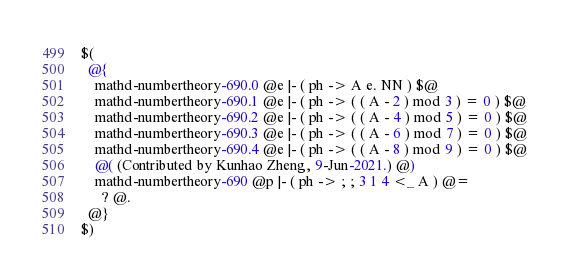<code> <loc_0><loc_0><loc_500><loc_500><_ObjectiveC_>$(
  @{
    mathd-numbertheory-690.0 @e |- ( ph -> A e. NN ) $@
    mathd-numbertheory-690.1 @e |- ( ph -> ( ( A - 2 ) mod 3 ) = 0 ) $@
    mathd-numbertheory-690.2 @e |- ( ph -> ( ( A - 4 ) mod 5 ) = 0 ) $@
    mathd-numbertheory-690.3 @e |- ( ph -> ( ( A - 6 ) mod 7 ) = 0 ) $@
    mathd-numbertheory-690.4 @e |- ( ph -> ( ( A - 8 ) mod 9 ) = 0 ) $@
    @( (Contributed by Kunhao Zheng, 9-Jun-2021.) @)
    mathd-numbertheory-690 @p |- ( ph -> ; ; 3 1 4 <_ A ) @=
      ? @.
  @}
$)
</code> 